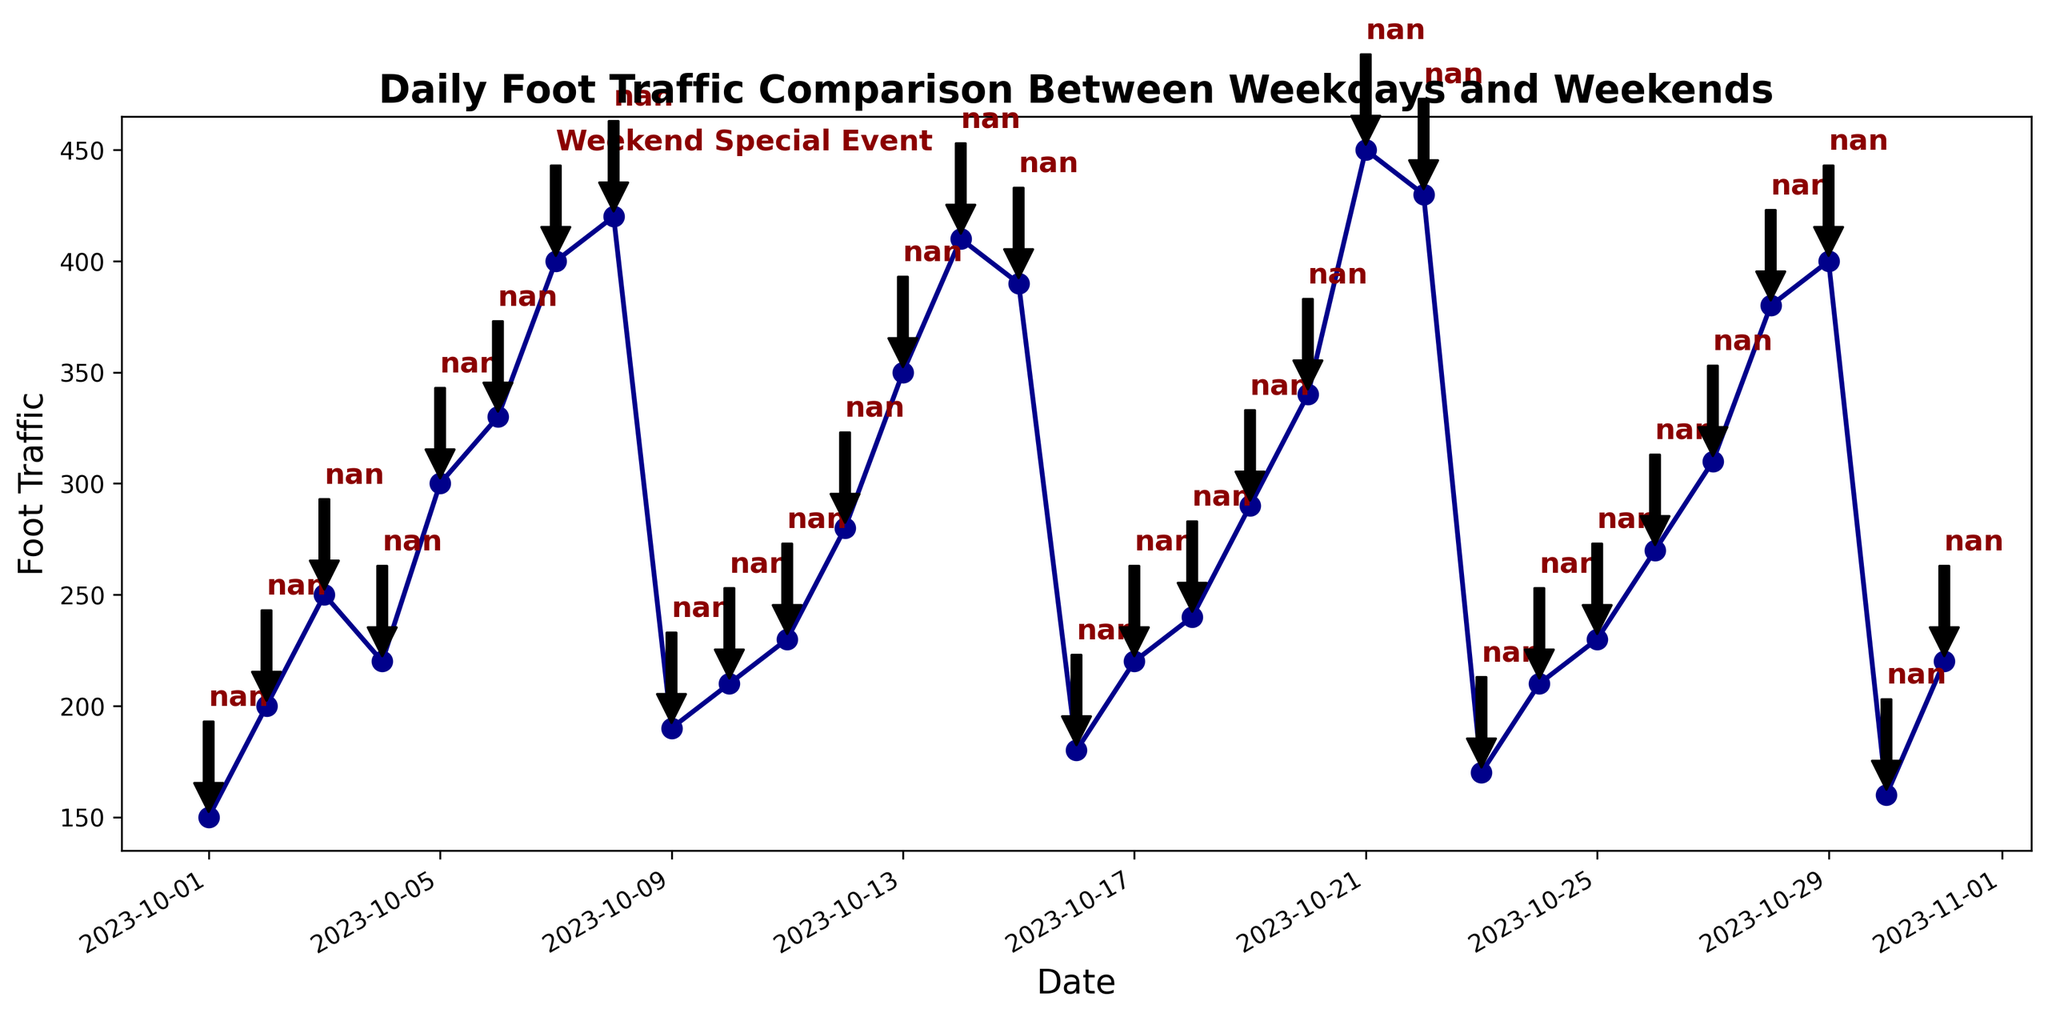What's the average foot traffic on weekends? To find the average foot traffic on weekends, identify the dates and values corresponding to Saturdays and Sundays. For example, October 7: 400, October 8: 420, October 14: 410, October 15: 390, October 21: 450, October 22: 430, October 28: 380, October 29: 400. Sum these, which is 3280, and divide by the number of weekend days (8) to get the average foot traffic.
Answer: 410 What day had the highest foot traffic? Check the foot traffic values across all dates to find the highest number. October 21 has the highest foot traffic at 450.
Answer: October 21 How does the foot traffic on October 7 compare to October 8? Check the foot traffic values for October 7 and October 8. October 7 had 400 while October 8 had 420, so October 8 had more foot traffic.
Answer: October 8 had more What is the trend in foot traffic during weekdays? Observe the general pattern of weekdays (Monday to Friday). The foot traffic generally increases from Monday to Friday. For example, in one week: Monday (200), Tuesday (250), Wednesday (220), Thursday (300), Friday (330).
Answer: Increasing trend What is the difference in foot traffic between October 7 and October 8? The foot traffic on October 7 is 400 and on October 8 is 420. The difference is 420 - 400 = 20.
Answer: 20 What is the foot traffic on the day with a special event? Check the annotation for any special event. On October 7, there is a "Weekend Special Event," and the foot traffic is 400.
Answer: 400 How does the foot traffic on October 9 compare to October 10? The foot traffic on October 9 is 190 while on October 10 is 210. October 10 had more foot traffic.
Answer: October 10 had more Which day has the lowest foot traffic in October? Check all foot traffic values to find the lowest. October 30 has the lowest foot traffic with a value of 160.
Answer: October 30 What's the average weekday foot traffic in the last week of October? Identify and sum the weekday values from the last week (October 23-27: 170, 210, 230, 270, 310). The sum is 1190. Divide by 5 (number of weekdays): 1190/5 = 238.
Answer: 238 